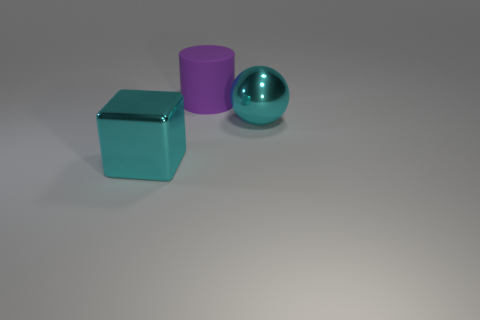What is the shape of the shiny thing that is the same color as the large metallic sphere?
Keep it short and to the point. Cube. Does the ball have the same color as the large block?
Your answer should be very brief. Yes. There is a big ball right of the big cylinder; does it have the same color as the metallic thing that is to the left of the large metal ball?
Ensure brevity in your answer.  Yes. Is the number of big things less than the number of big cyan spheres?
Your answer should be compact. No. There is a cyan block that is the same size as the shiny sphere; what is its material?
Your answer should be very brief. Metal. Do the metallic ball that is in front of the big purple thing and the cyan object that is left of the big metallic ball have the same size?
Provide a succinct answer. Yes. Is there a large red cylinder that has the same material as the cyan cube?
Your answer should be compact. No. How many objects are big cyan objects that are on the left side of the sphere or large blue shiny cubes?
Provide a short and direct response. 1. Is the material of the big cyan object in front of the cyan ball the same as the large purple cylinder?
Offer a very short reply. No. There is a big cyan thing to the right of the big matte cylinder; how many cyan metallic spheres are right of it?
Your response must be concise. 0. 